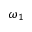Convert formula to latex. <formula><loc_0><loc_0><loc_500><loc_500>\omega _ { 1 }</formula> 